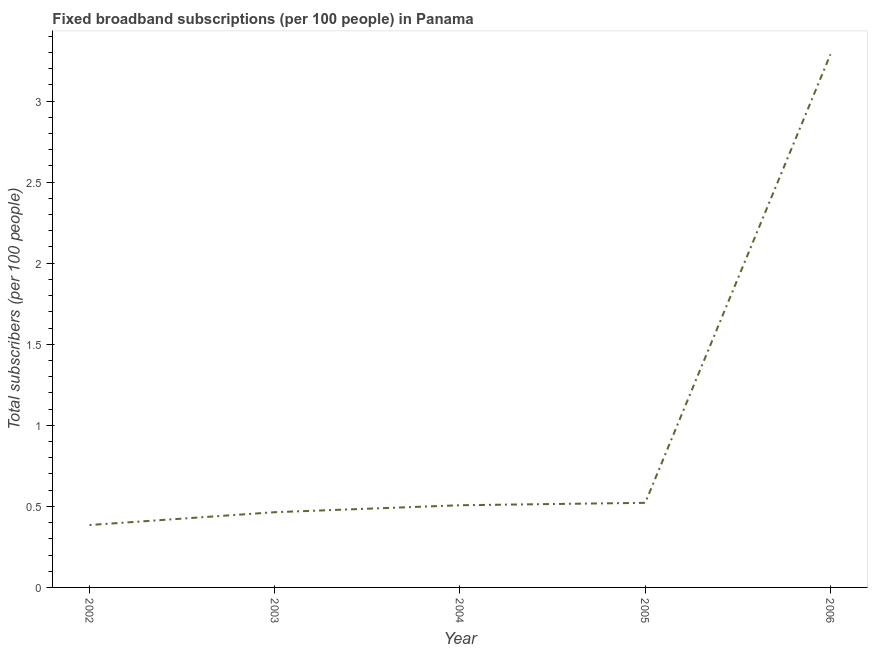What is the total number of fixed broadband subscriptions in 2004?
Provide a short and direct response. 0.51. Across all years, what is the maximum total number of fixed broadband subscriptions?
Keep it short and to the point. 3.29. Across all years, what is the minimum total number of fixed broadband subscriptions?
Your response must be concise. 0.38. What is the sum of the total number of fixed broadband subscriptions?
Give a very brief answer. 5.17. What is the difference between the total number of fixed broadband subscriptions in 2003 and 2006?
Your response must be concise. -2.82. What is the average total number of fixed broadband subscriptions per year?
Your response must be concise. 1.03. What is the median total number of fixed broadband subscriptions?
Your answer should be very brief. 0.51. What is the ratio of the total number of fixed broadband subscriptions in 2003 to that in 2006?
Offer a terse response. 0.14. Is the total number of fixed broadband subscriptions in 2002 less than that in 2005?
Ensure brevity in your answer.  Yes. What is the difference between the highest and the second highest total number of fixed broadband subscriptions?
Your response must be concise. 2.77. Is the sum of the total number of fixed broadband subscriptions in 2002 and 2004 greater than the maximum total number of fixed broadband subscriptions across all years?
Your answer should be compact. No. What is the difference between the highest and the lowest total number of fixed broadband subscriptions?
Give a very brief answer. 2.9. In how many years, is the total number of fixed broadband subscriptions greater than the average total number of fixed broadband subscriptions taken over all years?
Make the answer very short. 1. Does the total number of fixed broadband subscriptions monotonically increase over the years?
Your response must be concise. Yes. What is the title of the graph?
Your answer should be compact. Fixed broadband subscriptions (per 100 people) in Panama. What is the label or title of the X-axis?
Offer a very short reply. Year. What is the label or title of the Y-axis?
Your answer should be compact. Total subscribers (per 100 people). What is the Total subscribers (per 100 people) of 2002?
Keep it short and to the point. 0.38. What is the Total subscribers (per 100 people) of 2003?
Offer a terse response. 0.46. What is the Total subscribers (per 100 people) in 2004?
Ensure brevity in your answer.  0.51. What is the Total subscribers (per 100 people) of 2005?
Provide a succinct answer. 0.52. What is the Total subscribers (per 100 people) of 2006?
Provide a succinct answer. 3.29. What is the difference between the Total subscribers (per 100 people) in 2002 and 2003?
Your answer should be very brief. -0.08. What is the difference between the Total subscribers (per 100 people) in 2002 and 2004?
Make the answer very short. -0.12. What is the difference between the Total subscribers (per 100 people) in 2002 and 2005?
Ensure brevity in your answer.  -0.14. What is the difference between the Total subscribers (per 100 people) in 2002 and 2006?
Make the answer very short. -2.9. What is the difference between the Total subscribers (per 100 people) in 2003 and 2004?
Your response must be concise. -0.04. What is the difference between the Total subscribers (per 100 people) in 2003 and 2005?
Give a very brief answer. -0.06. What is the difference between the Total subscribers (per 100 people) in 2003 and 2006?
Your answer should be very brief. -2.82. What is the difference between the Total subscribers (per 100 people) in 2004 and 2005?
Give a very brief answer. -0.01. What is the difference between the Total subscribers (per 100 people) in 2004 and 2006?
Your response must be concise. -2.78. What is the difference between the Total subscribers (per 100 people) in 2005 and 2006?
Provide a short and direct response. -2.77. What is the ratio of the Total subscribers (per 100 people) in 2002 to that in 2003?
Give a very brief answer. 0.83. What is the ratio of the Total subscribers (per 100 people) in 2002 to that in 2004?
Provide a short and direct response. 0.76. What is the ratio of the Total subscribers (per 100 people) in 2002 to that in 2005?
Make the answer very short. 0.74. What is the ratio of the Total subscribers (per 100 people) in 2002 to that in 2006?
Provide a short and direct response. 0.12. What is the ratio of the Total subscribers (per 100 people) in 2003 to that in 2004?
Make the answer very short. 0.92. What is the ratio of the Total subscribers (per 100 people) in 2003 to that in 2005?
Provide a succinct answer. 0.89. What is the ratio of the Total subscribers (per 100 people) in 2003 to that in 2006?
Ensure brevity in your answer.  0.14. What is the ratio of the Total subscribers (per 100 people) in 2004 to that in 2006?
Your response must be concise. 0.15. What is the ratio of the Total subscribers (per 100 people) in 2005 to that in 2006?
Provide a succinct answer. 0.16. 